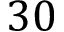Convert formula to latex. <formula><loc_0><loc_0><loc_500><loc_500>3 0</formula> 